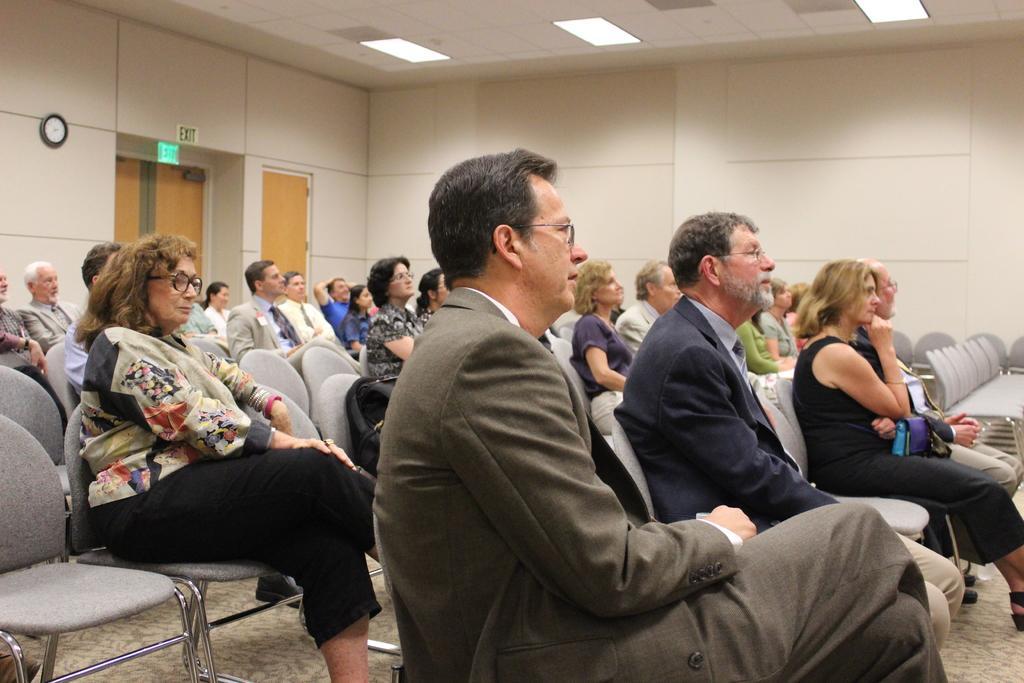Describe this image in one or two sentences. There is a group of people who are sitting on a chair and listening to someone's speech. 